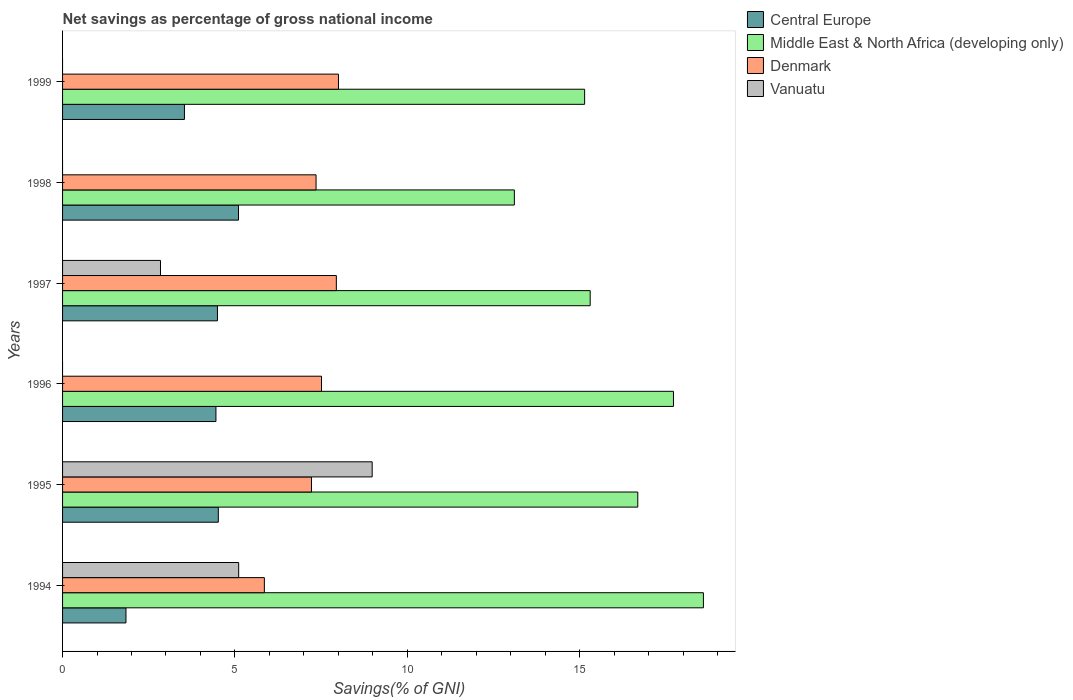How many different coloured bars are there?
Offer a very short reply. 4. Are the number of bars per tick equal to the number of legend labels?
Provide a succinct answer. No. How many bars are there on the 4th tick from the bottom?
Make the answer very short. 4. What is the label of the 6th group of bars from the top?
Offer a very short reply. 1994. In how many cases, is the number of bars for a given year not equal to the number of legend labels?
Provide a short and direct response. 3. What is the total savings in Middle East & North Africa (developing only) in 1997?
Offer a terse response. 15.31. Across all years, what is the maximum total savings in Vanuatu?
Offer a terse response. 8.98. Across all years, what is the minimum total savings in Vanuatu?
Your answer should be very brief. 0. In which year was the total savings in Central Europe maximum?
Provide a short and direct response. 1998. What is the total total savings in Central Europe in the graph?
Offer a very short reply. 23.94. What is the difference between the total savings in Middle East & North Africa (developing only) in 1994 and that in 1995?
Offer a terse response. 1.9. What is the difference between the total savings in Vanuatu in 1997 and the total savings in Middle East & North Africa (developing only) in 1998?
Give a very brief answer. -10.27. What is the average total savings in Central Europe per year?
Ensure brevity in your answer.  3.99. In the year 1998, what is the difference between the total savings in Central Europe and total savings in Denmark?
Your answer should be compact. -2.25. What is the ratio of the total savings in Middle East & North Africa (developing only) in 1994 to that in 1998?
Keep it short and to the point. 1.42. Is the difference between the total savings in Central Europe in 1994 and 1995 greater than the difference between the total savings in Denmark in 1994 and 1995?
Offer a very short reply. No. What is the difference between the highest and the second highest total savings in Middle East & North Africa (developing only)?
Your answer should be very brief. 0.87. What is the difference between the highest and the lowest total savings in Central Europe?
Keep it short and to the point. 3.26. In how many years, is the total savings in Middle East & North Africa (developing only) greater than the average total savings in Middle East & North Africa (developing only) taken over all years?
Keep it short and to the point. 3. Is the sum of the total savings in Central Europe in 1994 and 1998 greater than the maximum total savings in Denmark across all years?
Provide a succinct answer. No. Is it the case that in every year, the sum of the total savings in Central Europe and total savings in Vanuatu is greater than the sum of total savings in Denmark and total savings in Middle East & North Africa (developing only)?
Provide a succinct answer. No. Is it the case that in every year, the sum of the total savings in Central Europe and total savings in Denmark is greater than the total savings in Middle East & North Africa (developing only)?
Give a very brief answer. No. Are all the bars in the graph horizontal?
Offer a terse response. Yes. How many years are there in the graph?
Offer a very short reply. 6. Are the values on the major ticks of X-axis written in scientific E-notation?
Keep it short and to the point. No. Does the graph contain any zero values?
Ensure brevity in your answer.  Yes. How many legend labels are there?
Your answer should be very brief. 4. What is the title of the graph?
Offer a terse response. Net savings as percentage of gross national income. What is the label or title of the X-axis?
Keep it short and to the point. Savings(% of GNI). What is the label or title of the Y-axis?
Offer a terse response. Years. What is the Savings(% of GNI) of Central Europe in 1994?
Provide a short and direct response. 1.84. What is the Savings(% of GNI) of Middle East & North Africa (developing only) in 1994?
Ensure brevity in your answer.  18.59. What is the Savings(% of GNI) in Denmark in 1994?
Your answer should be very brief. 5.85. What is the Savings(% of GNI) of Vanuatu in 1994?
Your answer should be very brief. 5.11. What is the Savings(% of GNI) in Central Europe in 1995?
Make the answer very short. 4.52. What is the Savings(% of GNI) in Middle East & North Africa (developing only) in 1995?
Offer a very short reply. 16.69. What is the Savings(% of GNI) of Denmark in 1995?
Make the answer very short. 7.22. What is the Savings(% of GNI) in Vanuatu in 1995?
Your answer should be very brief. 8.98. What is the Savings(% of GNI) of Central Europe in 1996?
Your answer should be very brief. 4.45. What is the Savings(% of GNI) of Middle East & North Africa (developing only) in 1996?
Your answer should be compact. 17.72. What is the Savings(% of GNI) in Denmark in 1996?
Your response must be concise. 7.51. What is the Savings(% of GNI) of Central Europe in 1997?
Offer a very short reply. 4.49. What is the Savings(% of GNI) of Middle East & North Africa (developing only) in 1997?
Your answer should be compact. 15.31. What is the Savings(% of GNI) of Denmark in 1997?
Ensure brevity in your answer.  7.94. What is the Savings(% of GNI) of Vanuatu in 1997?
Provide a succinct answer. 2.84. What is the Savings(% of GNI) in Central Europe in 1998?
Give a very brief answer. 5.1. What is the Savings(% of GNI) in Middle East & North Africa (developing only) in 1998?
Your response must be concise. 13.11. What is the Savings(% of GNI) of Denmark in 1998?
Ensure brevity in your answer.  7.35. What is the Savings(% of GNI) of Central Europe in 1999?
Give a very brief answer. 3.54. What is the Savings(% of GNI) of Middle East & North Africa (developing only) in 1999?
Provide a short and direct response. 15.15. What is the Savings(% of GNI) of Denmark in 1999?
Give a very brief answer. 8. Across all years, what is the maximum Savings(% of GNI) of Central Europe?
Give a very brief answer. 5.1. Across all years, what is the maximum Savings(% of GNI) of Middle East & North Africa (developing only)?
Your answer should be very brief. 18.59. Across all years, what is the maximum Savings(% of GNI) in Denmark?
Keep it short and to the point. 8. Across all years, what is the maximum Savings(% of GNI) in Vanuatu?
Provide a succinct answer. 8.98. Across all years, what is the minimum Savings(% of GNI) in Central Europe?
Keep it short and to the point. 1.84. Across all years, what is the minimum Savings(% of GNI) of Middle East & North Africa (developing only)?
Provide a short and direct response. 13.11. Across all years, what is the minimum Savings(% of GNI) in Denmark?
Make the answer very short. 5.85. What is the total Savings(% of GNI) of Central Europe in the graph?
Your answer should be compact. 23.94. What is the total Savings(% of GNI) of Middle East & North Africa (developing only) in the graph?
Offer a terse response. 96.56. What is the total Savings(% of GNI) in Denmark in the graph?
Keep it short and to the point. 43.89. What is the total Savings(% of GNI) of Vanuatu in the graph?
Offer a terse response. 16.93. What is the difference between the Savings(% of GNI) in Central Europe in 1994 and that in 1995?
Give a very brief answer. -2.68. What is the difference between the Savings(% of GNI) of Middle East & North Africa (developing only) in 1994 and that in 1995?
Offer a very short reply. 1.9. What is the difference between the Savings(% of GNI) of Denmark in 1994 and that in 1995?
Provide a short and direct response. -1.37. What is the difference between the Savings(% of GNI) in Vanuatu in 1994 and that in 1995?
Make the answer very short. -3.87. What is the difference between the Savings(% of GNI) in Central Europe in 1994 and that in 1996?
Keep it short and to the point. -2.61. What is the difference between the Savings(% of GNI) in Middle East & North Africa (developing only) in 1994 and that in 1996?
Give a very brief answer. 0.87. What is the difference between the Savings(% of GNI) in Denmark in 1994 and that in 1996?
Your answer should be very brief. -1.66. What is the difference between the Savings(% of GNI) of Central Europe in 1994 and that in 1997?
Offer a very short reply. -2.65. What is the difference between the Savings(% of GNI) of Middle East & North Africa (developing only) in 1994 and that in 1997?
Offer a terse response. 3.28. What is the difference between the Savings(% of GNI) of Denmark in 1994 and that in 1997?
Provide a short and direct response. -2.09. What is the difference between the Savings(% of GNI) of Vanuatu in 1994 and that in 1997?
Your answer should be very brief. 2.27. What is the difference between the Savings(% of GNI) of Central Europe in 1994 and that in 1998?
Offer a terse response. -3.26. What is the difference between the Savings(% of GNI) of Middle East & North Africa (developing only) in 1994 and that in 1998?
Your answer should be very brief. 5.48. What is the difference between the Savings(% of GNI) in Denmark in 1994 and that in 1998?
Your answer should be compact. -1.5. What is the difference between the Savings(% of GNI) in Central Europe in 1994 and that in 1999?
Your answer should be compact. -1.7. What is the difference between the Savings(% of GNI) of Middle East & North Africa (developing only) in 1994 and that in 1999?
Provide a succinct answer. 3.45. What is the difference between the Savings(% of GNI) in Denmark in 1994 and that in 1999?
Make the answer very short. -2.15. What is the difference between the Savings(% of GNI) of Central Europe in 1995 and that in 1996?
Make the answer very short. 0.07. What is the difference between the Savings(% of GNI) in Middle East & North Africa (developing only) in 1995 and that in 1996?
Your answer should be very brief. -1.04. What is the difference between the Savings(% of GNI) in Denmark in 1995 and that in 1996?
Offer a terse response. -0.29. What is the difference between the Savings(% of GNI) in Central Europe in 1995 and that in 1997?
Ensure brevity in your answer.  0.03. What is the difference between the Savings(% of GNI) in Middle East & North Africa (developing only) in 1995 and that in 1997?
Keep it short and to the point. 1.38. What is the difference between the Savings(% of GNI) of Denmark in 1995 and that in 1997?
Offer a very short reply. -0.72. What is the difference between the Savings(% of GNI) in Vanuatu in 1995 and that in 1997?
Offer a very short reply. 6.14. What is the difference between the Savings(% of GNI) of Central Europe in 1995 and that in 1998?
Your answer should be compact. -0.59. What is the difference between the Savings(% of GNI) in Middle East & North Africa (developing only) in 1995 and that in 1998?
Offer a terse response. 3.58. What is the difference between the Savings(% of GNI) of Denmark in 1995 and that in 1998?
Your answer should be very brief. -0.13. What is the difference between the Savings(% of GNI) in Central Europe in 1995 and that in 1999?
Offer a terse response. 0.98. What is the difference between the Savings(% of GNI) in Middle East & North Africa (developing only) in 1995 and that in 1999?
Your answer should be compact. 1.54. What is the difference between the Savings(% of GNI) of Denmark in 1995 and that in 1999?
Make the answer very short. -0.78. What is the difference between the Savings(% of GNI) of Central Europe in 1996 and that in 1997?
Your answer should be very brief. -0.04. What is the difference between the Savings(% of GNI) of Middle East & North Africa (developing only) in 1996 and that in 1997?
Offer a terse response. 2.42. What is the difference between the Savings(% of GNI) of Denmark in 1996 and that in 1997?
Ensure brevity in your answer.  -0.43. What is the difference between the Savings(% of GNI) in Central Europe in 1996 and that in 1998?
Your answer should be very brief. -0.65. What is the difference between the Savings(% of GNI) in Middle East & North Africa (developing only) in 1996 and that in 1998?
Your answer should be very brief. 4.62. What is the difference between the Savings(% of GNI) of Denmark in 1996 and that in 1998?
Offer a very short reply. 0.16. What is the difference between the Savings(% of GNI) of Central Europe in 1996 and that in 1999?
Your response must be concise. 0.91. What is the difference between the Savings(% of GNI) of Middle East & North Africa (developing only) in 1996 and that in 1999?
Provide a short and direct response. 2.58. What is the difference between the Savings(% of GNI) in Denmark in 1996 and that in 1999?
Offer a terse response. -0.49. What is the difference between the Savings(% of GNI) of Central Europe in 1997 and that in 1998?
Make the answer very short. -0.61. What is the difference between the Savings(% of GNI) in Middle East & North Africa (developing only) in 1997 and that in 1998?
Your answer should be very brief. 2.2. What is the difference between the Savings(% of GNI) in Denmark in 1997 and that in 1998?
Give a very brief answer. 0.59. What is the difference between the Savings(% of GNI) of Central Europe in 1997 and that in 1999?
Your answer should be compact. 0.96. What is the difference between the Savings(% of GNI) in Middle East & North Africa (developing only) in 1997 and that in 1999?
Provide a succinct answer. 0.16. What is the difference between the Savings(% of GNI) of Denmark in 1997 and that in 1999?
Ensure brevity in your answer.  -0.06. What is the difference between the Savings(% of GNI) of Central Europe in 1998 and that in 1999?
Provide a short and direct response. 1.57. What is the difference between the Savings(% of GNI) in Middle East & North Africa (developing only) in 1998 and that in 1999?
Offer a very short reply. -2.04. What is the difference between the Savings(% of GNI) in Denmark in 1998 and that in 1999?
Ensure brevity in your answer.  -0.65. What is the difference between the Savings(% of GNI) of Central Europe in 1994 and the Savings(% of GNI) of Middle East & North Africa (developing only) in 1995?
Make the answer very short. -14.85. What is the difference between the Savings(% of GNI) in Central Europe in 1994 and the Savings(% of GNI) in Denmark in 1995?
Ensure brevity in your answer.  -5.38. What is the difference between the Savings(% of GNI) in Central Europe in 1994 and the Savings(% of GNI) in Vanuatu in 1995?
Make the answer very short. -7.14. What is the difference between the Savings(% of GNI) of Middle East & North Africa (developing only) in 1994 and the Savings(% of GNI) of Denmark in 1995?
Make the answer very short. 11.37. What is the difference between the Savings(% of GNI) in Middle East & North Africa (developing only) in 1994 and the Savings(% of GNI) in Vanuatu in 1995?
Provide a succinct answer. 9.61. What is the difference between the Savings(% of GNI) in Denmark in 1994 and the Savings(% of GNI) in Vanuatu in 1995?
Make the answer very short. -3.13. What is the difference between the Savings(% of GNI) of Central Europe in 1994 and the Savings(% of GNI) of Middle East & North Africa (developing only) in 1996?
Offer a terse response. -15.88. What is the difference between the Savings(% of GNI) of Central Europe in 1994 and the Savings(% of GNI) of Denmark in 1996?
Your answer should be compact. -5.67. What is the difference between the Savings(% of GNI) of Middle East & North Africa (developing only) in 1994 and the Savings(% of GNI) of Denmark in 1996?
Offer a terse response. 11.08. What is the difference between the Savings(% of GNI) of Central Europe in 1994 and the Savings(% of GNI) of Middle East & North Africa (developing only) in 1997?
Provide a succinct answer. -13.47. What is the difference between the Savings(% of GNI) of Central Europe in 1994 and the Savings(% of GNI) of Denmark in 1997?
Provide a succinct answer. -6.1. What is the difference between the Savings(% of GNI) in Central Europe in 1994 and the Savings(% of GNI) in Vanuatu in 1997?
Your answer should be very brief. -1. What is the difference between the Savings(% of GNI) in Middle East & North Africa (developing only) in 1994 and the Savings(% of GNI) in Denmark in 1997?
Make the answer very short. 10.65. What is the difference between the Savings(% of GNI) of Middle East & North Africa (developing only) in 1994 and the Savings(% of GNI) of Vanuatu in 1997?
Provide a short and direct response. 15.75. What is the difference between the Savings(% of GNI) in Denmark in 1994 and the Savings(% of GNI) in Vanuatu in 1997?
Give a very brief answer. 3.01. What is the difference between the Savings(% of GNI) in Central Europe in 1994 and the Savings(% of GNI) in Middle East & North Africa (developing only) in 1998?
Make the answer very short. -11.27. What is the difference between the Savings(% of GNI) in Central Europe in 1994 and the Savings(% of GNI) in Denmark in 1998?
Keep it short and to the point. -5.51. What is the difference between the Savings(% of GNI) of Middle East & North Africa (developing only) in 1994 and the Savings(% of GNI) of Denmark in 1998?
Ensure brevity in your answer.  11.24. What is the difference between the Savings(% of GNI) of Central Europe in 1994 and the Savings(% of GNI) of Middle East & North Africa (developing only) in 1999?
Provide a succinct answer. -13.31. What is the difference between the Savings(% of GNI) of Central Europe in 1994 and the Savings(% of GNI) of Denmark in 1999?
Make the answer very short. -6.16. What is the difference between the Savings(% of GNI) of Middle East & North Africa (developing only) in 1994 and the Savings(% of GNI) of Denmark in 1999?
Give a very brief answer. 10.59. What is the difference between the Savings(% of GNI) of Central Europe in 1995 and the Savings(% of GNI) of Middle East & North Africa (developing only) in 1996?
Keep it short and to the point. -13.2. What is the difference between the Savings(% of GNI) in Central Europe in 1995 and the Savings(% of GNI) in Denmark in 1996?
Give a very brief answer. -2.99. What is the difference between the Savings(% of GNI) of Middle East & North Africa (developing only) in 1995 and the Savings(% of GNI) of Denmark in 1996?
Your response must be concise. 9.18. What is the difference between the Savings(% of GNI) of Central Europe in 1995 and the Savings(% of GNI) of Middle East & North Africa (developing only) in 1997?
Your answer should be compact. -10.79. What is the difference between the Savings(% of GNI) of Central Europe in 1995 and the Savings(% of GNI) of Denmark in 1997?
Offer a very short reply. -3.42. What is the difference between the Savings(% of GNI) of Central Europe in 1995 and the Savings(% of GNI) of Vanuatu in 1997?
Your answer should be compact. 1.68. What is the difference between the Savings(% of GNI) of Middle East & North Africa (developing only) in 1995 and the Savings(% of GNI) of Denmark in 1997?
Offer a very short reply. 8.74. What is the difference between the Savings(% of GNI) of Middle East & North Africa (developing only) in 1995 and the Savings(% of GNI) of Vanuatu in 1997?
Ensure brevity in your answer.  13.85. What is the difference between the Savings(% of GNI) of Denmark in 1995 and the Savings(% of GNI) of Vanuatu in 1997?
Your response must be concise. 4.38. What is the difference between the Savings(% of GNI) of Central Europe in 1995 and the Savings(% of GNI) of Middle East & North Africa (developing only) in 1998?
Give a very brief answer. -8.59. What is the difference between the Savings(% of GNI) of Central Europe in 1995 and the Savings(% of GNI) of Denmark in 1998?
Your response must be concise. -2.84. What is the difference between the Savings(% of GNI) in Middle East & North Africa (developing only) in 1995 and the Savings(% of GNI) in Denmark in 1998?
Provide a short and direct response. 9.33. What is the difference between the Savings(% of GNI) of Central Europe in 1995 and the Savings(% of GNI) of Middle East & North Africa (developing only) in 1999?
Keep it short and to the point. -10.63. What is the difference between the Savings(% of GNI) of Central Europe in 1995 and the Savings(% of GNI) of Denmark in 1999?
Keep it short and to the point. -3.49. What is the difference between the Savings(% of GNI) in Middle East & North Africa (developing only) in 1995 and the Savings(% of GNI) in Denmark in 1999?
Make the answer very short. 8.68. What is the difference between the Savings(% of GNI) of Central Europe in 1996 and the Savings(% of GNI) of Middle East & North Africa (developing only) in 1997?
Keep it short and to the point. -10.86. What is the difference between the Savings(% of GNI) of Central Europe in 1996 and the Savings(% of GNI) of Denmark in 1997?
Provide a succinct answer. -3.49. What is the difference between the Savings(% of GNI) of Central Europe in 1996 and the Savings(% of GNI) of Vanuatu in 1997?
Keep it short and to the point. 1.61. What is the difference between the Savings(% of GNI) in Middle East & North Africa (developing only) in 1996 and the Savings(% of GNI) in Denmark in 1997?
Provide a succinct answer. 9.78. What is the difference between the Savings(% of GNI) of Middle East & North Africa (developing only) in 1996 and the Savings(% of GNI) of Vanuatu in 1997?
Make the answer very short. 14.88. What is the difference between the Savings(% of GNI) in Denmark in 1996 and the Savings(% of GNI) in Vanuatu in 1997?
Provide a succinct answer. 4.67. What is the difference between the Savings(% of GNI) in Central Europe in 1996 and the Savings(% of GNI) in Middle East & North Africa (developing only) in 1998?
Your response must be concise. -8.66. What is the difference between the Savings(% of GNI) of Central Europe in 1996 and the Savings(% of GNI) of Denmark in 1998?
Give a very brief answer. -2.9. What is the difference between the Savings(% of GNI) of Middle East & North Africa (developing only) in 1996 and the Savings(% of GNI) of Denmark in 1998?
Your response must be concise. 10.37. What is the difference between the Savings(% of GNI) in Central Europe in 1996 and the Savings(% of GNI) in Middle East & North Africa (developing only) in 1999?
Your answer should be very brief. -10.7. What is the difference between the Savings(% of GNI) in Central Europe in 1996 and the Savings(% of GNI) in Denmark in 1999?
Provide a short and direct response. -3.55. What is the difference between the Savings(% of GNI) of Middle East & North Africa (developing only) in 1996 and the Savings(% of GNI) of Denmark in 1999?
Offer a very short reply. 9.72. What is the difference between the Savings(% of GNI) in Central Europe in 1997 and the Savings(% of GNI) in Middle East & North Africa (developing only) in 1998?
Offer a very short reply. -8.61. What is the difference between the Savings(% of GNI) in Central Europe in 1997 and the Savings(% of GNI) in Denmark in 1998?
Make the answer very short. -2.86. What is the difference between the Savings(% of GNI) of Middle East & North Africa (developing only) in 1997 and the Savings(% of GNI) of Denmark in 1998?
Keep it short and to the point. 7.95. What is the difference between the Savings(% of GNI) in Central Europe in 1997 and the Savings(% of GNI) in Middle East & North Africa (developing only) in 1999?
Your answer should be very brief. -10.65. What is the difference between the Savings(% of GNI) in Central Europe in 1997 and the Savings(% of GNI) in Denmark in 1999?
Make the answer very short. -3.51. What is the difference between the Savings(% of GNI) of Middle East & North Africa (developing only) in 1997 and the Savings(% of GNI) of Denmark in 1999?
Provide a succinct answer. 7.3. What is the difference between the Savings(% of GNI) in Central Europe in 1998 and the Savings(% of GNI) in Middle East & North Africa (developing only) in 1999?
Keep it short and to the point. -10.04. What is the difference between the Savings(% of GNI) in Central Europe in 1998 and the Savings(% of GNI) in Denmark in 1999?
Make the answer very short. -2.9. What is the difference between the Savings(% of GNI) of Middle East & North Africa (developing only) in 1998 and the Savings(% of GNI) of Denmark in 1999?
Keep it short and to the point. 5.1. What is the average Savings(% of GNI) in Central Europe per year?
Offer a very short reply. 3.99. What is the average Savings(% of GNI) of Middle East & North Africa (developing only) per year?
Keep it short and to the point. 16.09. What is the average Savings(% of GNI) of Denmark per year?
Keep it short and to the point. 7.31. What is the average Savings(% of GNI) of Vanuatu per year?
Offer a terse response. 2.82. In the year 1994, what is the difference between the Savings(% of GNI) of Central Europe and Savings(% of GNI) of Middle East & North Africa (developing only)?
Provide a succinct answer. -16.75. In the year 1994, what is the difference between the Savings(% of GNI) in Central Europe and Savings(% of GNI) in Denmark?
Make the answer very short. -4.01. In the year 1994, what is the difference between the Savings(% of GNI) of Central Europe and Savings(% of GNI) of Vanuatu?
Make the answer very short. -3.27. In the year 1994, what is the difference between the Savings(% of GNI) in Middle East & North Africa (developing only) and Savings(% of GNI) in Denmark?
Give a very brief answer. 12.74. In the year 1994, what is the difference between the Savings(% of GNI) of Middle East & North Africa (developing only) and Savings(% of GNI) of Vanuatu?
Offer a terse response. 13.48. In the year 1994, what is the difference between the Savings(% of GNI) of Denmark and Savings(% of GNI) of Vanuatu?
Give a very brief answer. 0.75. In the year 1995, what is the difference between the Savings(% of GNI) in Central Europe and Savings(% of GNI) in Middle East & North Africa (developing only)?
Your answer should be very brief. -12.17. In the year 1995, what is the difference between the Savings(% of GNI) in Central Europe and Savings(% of GNI) in Denmark?
Offer a very short reply. -2.7. In the year 1995, what is the difference between the Savings(% of GNI) in Central Europe and Savings(% of GNI) in Vanuatu?
Make the answer very short. -4.46. In the year 1995, what is the difference between the Savings(% of GNI) in Middle East & North Africa (developing only) and Savings(% of GNI) in Denmark?
Provide a short and direct response. 9.47. In the year 1995, what is the difference between the Savings(% of GNI) in Middle East & North Africa (developing only) and Savings(% of GNI) in Vanuatu?
Give a very brief answer. 7.71. In the year 1995, what is the difference between the Savings(% of GNI) of Denmark and Savings(% of GNI) of Vanuatu?
Provide a short and direct response. -1.76. In the year 1996, what is the difference between the Savings(% of GNI) of Central Europe and Savings(% of GNI) of Middle East & North Africa (developing only)?
Your answer should be compact. -13.27. In the year 1996, what is the difference between the Savings(% of GNI) in Central Europe and Savings(% of GNI) in Denmark?
Your answer should be very brief. -3.06. In the year 1996, what is the difference between the Savings(% of GNI) of Middle East & North Africa (developing only) and Savings(% of GNI) of Denmark?
Ensure brevity in your answer.  10.21. In the year 1997, what is the difference between the Savings(% of GNI) of Central Europe and Savings(% of GNI) of Middle East & North Africa (developing only)?
Offer a very short reply. -10.81. In the year 1997, what is the difference between the Savings(% of GNI) in Central Europe and Savings(% of GNI) in Denmark?
Your answer should be compact. -3.45. In the year 1997, what is the difference between the Savings(% of GNI) of Central Europe and Savings(% of GNI) of Vanuatu?
Your response must be concise. 1.65. In the year 1997, what is the difference between the Savings(% of GNI) of Middle East & North Africa (developing only) and Savings(% of GNI) of Denmark?
Offer a terse response. 7.36. In the year 1997, what is the difference between the Savings(% of GNI) in Middle East & North Africa (developing only) and Savings(% of GNI) in Vanuatu?
Your answer should be compact. 12.47. In the year 1997, what is the difference between the Savings(% of GNI) of Denmark and Savings(% of GNI) of Vanuatu?
Your answer should be compact. 5.1. In the year 1998, what is the difference between the Savings(% of GNI) in Central Europe and Savings(% of GNI) in Middle East & North Africa (developing only)?
Provide a succinct answer. -8. In the year 1998, what is the difference between the Savings(% of GNI) in Central Europe and Savings(% of GNI) in Denmark?
Make the answer very short. -2.25. In the year 1998, what is the difference between the Savings(% of GNI) of Middle East & North Africa (developing only) and Savings(% of GNI) of Denmark?
Your response must be concise. 5.75. In the year 1999, what is the difference between the Savings(% of GNI) of Central Europe and Savings(% of GNI) of Middle East & North Africa (developing only)?
Your answer should be compact. -11.61. In the year 1999, what is the difference between the Savings(% of GNI) in Central Europe and Savings(% of GNI) in Denmark?
Provide a short and direct response. -4.47. In the year 1999, what is the difference between the Savings(% of GNI) of Middle East & North Africa (developing only) and Savings(% of GNI) of Denmark?
Your answer should be compact. 7.14. What is the ratio of the Savings(% of GNI) in Central Europe in 1994 to that in 1995?
Your answer should be compact. 0.41. What is the ratio of the Savings(% of GNI) in Middle East & North Africa (developing only) in 1994 to that in 1995?
Offer a very short reply. 1.11. What is the ratio of the Savings(% of GNI) of Denmark in 1994 to that in 1995?
Provide a succinct answer. 0.81. What is the ratio of the Savings(% of GNI) in Vanuatu in 1994 to that in 1995?
Your answer should be very brief. 0.57. What is the ratio of the Savings(% of GNI) in Central Europe in 1994 to that in 1996?
Offer a very short reply. 0.41. What is the ratio of the Savings(% of GNI) in Middle East & North Africa (developing only) in 1994 to that in 1996?
Your answer should be very brief. 1.05. What is the ratio of the Savings(% of GNI) of Denmark in 1994 to that in 1996?
Your response must be concise. 0.78. What is the ratio of the Savings(% of GNI) in Central Europe in 1994 to that in 1997?
Offer a very short reply. 0.41. What is the ratio of the Savings(% of GNI) in Middle East & North Africa (developing only) in 1994 to that in 1997?
Offer a terse response. 1.21. What is the ratio of the Savings(% of GNI) of Denmark in 1994 to that in 1997?
Make the answer very short. 0.74. What is the ratio of the Savings(% of GNI) of Vanuatu in 1994 to that in 1997?
Your answer should be very brief. 1.8. What is the ratio of the Savings(% of GNI) in Central Europe in 1994 to that in 1998?
Make the answer very short. 0.36. What is the ratio of the Savings(% of GNI) of Middle East & North Africa (developing only) in 1994 to that in 1998?
Make the answer very short. 1.42. What is the ratio of the Savings(% of GNI) in Denmark in 1994 to that in 1998?
Make the answer very short. 0.8. What is the ratio of the Savings(% of GNI) in Central Europe in 1994 to that in 1999?
Offer a terse response. 0.52. What is the ratio of the Savings(% of GNI) of Middle East & North Africa (developing only) in 1994 to that in 1999?
Give a very brief answer. 1.23. What is the ratio of the Savings(% of GNI) of Denmark in 1994 to that in 1999?
Provide a succinct answer. 0.73. What is the ratio of the Savings(% of GNI) in Central Europe in 1995 to that in 1996?
Offer a very short reply. 1.02. What is the ratio of the Savings(% of GNI) in Middle East & North Africa (developing only) in 1995 to that in 1996?
Offer a very short reply. 0.94. What is the ratio of the Savings(% of GNI) of Denmark in 1995 to that in 1996?
Your answer should be very brief. 0.96. What is the ratio of the Savings(% of GNI) in Central Europe in 1995 to that in 1997?
Your answer should be very brief. 1.01. What is the ratio of the Savings(% of GNI) in Middle East & North Africa (developing only) in 1995 to that in 1997?
Give a very brief answer. 1.09. What is the ratio of the Savings(% of GNI) of Denmark in 1995 to that in 1997?
Make the answer very short. 0.91. What is the ratio of the Savings(% of GNI) of Vanuatu in 1995 to that in 1997?
Your answer should be compact. 3.16. What is the ratio of the Savings(% of GNI) in Central Europe in 1995 to that in 1998?
Offer a very short reply. 0.89. What is the ratio of the Savings(% of GNI) of Middle East & North Africa (developing only) in 1995 to that in 1998?
Keep it short and to the point. 1.27. What is the ratio of the Savings(% of GNI) in Denmark in 1995 to that in 1998?
Ensure brevity in your answer.  0.98. What is the ratio of the Savings(% of GNI) in Central Europe in 1995 to that in 1999?
Make the answer very short. 1.28. What is the ratio of the Savings(% of GNI) in Middle East & North Africa (developing only) in 1995 to that in 1999?
Your answer should be very brief. 1.1. What is the ratio of the Savings(% of GNI) of Denmark in 1995 to that in 1999?
Make the answer very short. 0.9. What is the ratio of the Savings(% of GNI) of Central Europe in 1996 to that in 1997?
Your answer should be compact. 0.99. What is the ratio of the Savings(% of GNI) in Middle East & North Africa (developing only) in 1996 to that in 1997?
Make the answer very short. 1.16. What is the ratio of the Savings(% of GNI) in Denmark in 1996 to that in 1997?
Offer a very short reply. 0.95. What is the ratio of the Savings(% of GNI) in Central Europe in 1996 to that in 1998?
Provide a short and direct response. 0.87. What is the ratio of the Savings(% of GNI) of Middle East & North Africa (developing only) in 1996 to that in 1998?
Your answer should be very brief. 1.35. What is the ratio of the Savings(% of GNI) in Denmark in 1996 to that in 1998?
Provide a succinct answer. 1.02. What is the ratio of the Savings(% of GNI) of Central Europe in 1996 to that in 1999?
Keep it short and to the point. 1.26. What is the ratio of the Savings(% of GNI) of Middle East & North Africa (developing only) in 1996 to that in 1999?
Make the answer very short. 1.17. What is the ratio of the Savings(% of GNI) of Denmark in 1996 to that in 1999?
Your answer should be compact. 0.94. What is the ratio of the Savings(% of GNI) in Central Europe in 1997 to that in 1998?
Your answer should be very brief. 0.88. What is the ratio of the Savings(% of GNI) in Middle East & North Africa (developing only) in 1997 to that in 1998?
Keep it short and to the point. 1.17. What is the ratio of the Savings(% of GNI) of Denmark in 1997 to that in 1998?
Your answer should be compact. 1.08. What is the ratio of the Savings(% of GNI) of Central Europe in 1997 to that in 1999?
Offer a very short reply. 1.27. What is the ratio of the Savings(% of GNI) of Middle East & North Africa (developing only) in 1997 to that in 1999?
Offer a very short reply. 1.01. What is the ratio of the Savings(% of GNI) of Central Europe in 1998 to that in 1999?
Provide a short and direct response. 1.44. What is the ratio of the Savings(% of GNI) in Middle East & North Africa (developing only) in 1998 to that in 1999?
Offer a very short reply. 0.87. What is the ratio of the Savings(% of GNI) in Denmark in 1998 to that in 1999?
Your answer should be very brief. 0.92. What is the difference between the highest and the second highest Savings(% of GNI) in Central Europe?
Provide a short and direct response. 0.59. What is the difference between the highest and the second highest Savings(% of GNI) in Middle East & North Africa (developing only)?
Your answer should be very brief. 0.87. What is the difference between the highest and the second highest Savings(% of GNI) in Denmark?
Keep it short and to the point. 0.06. What is the difference between the highest and the second highest Savings(% of GNI) of Vanuatu?
Ensure brevity in your answer.  3.87. What is the difference between the highest and the lowest Savings(% of GNI) of Central Europe?
Keep it short and to the point. 3.26. What is the difference between the highest and the lowest Savings(% of GNI) in Middle East & North Africa (developing only)?
Your answer should be very brief. 5.48. What is the difference between the highest and the lowest Savings(% of GNI) in Denmark?
Your answer should be compact. 2.15. What is the difference between the highest and the lowest Savings(% of GNI) in Vanuatu?
Provide a short and direct response. 8.98. 